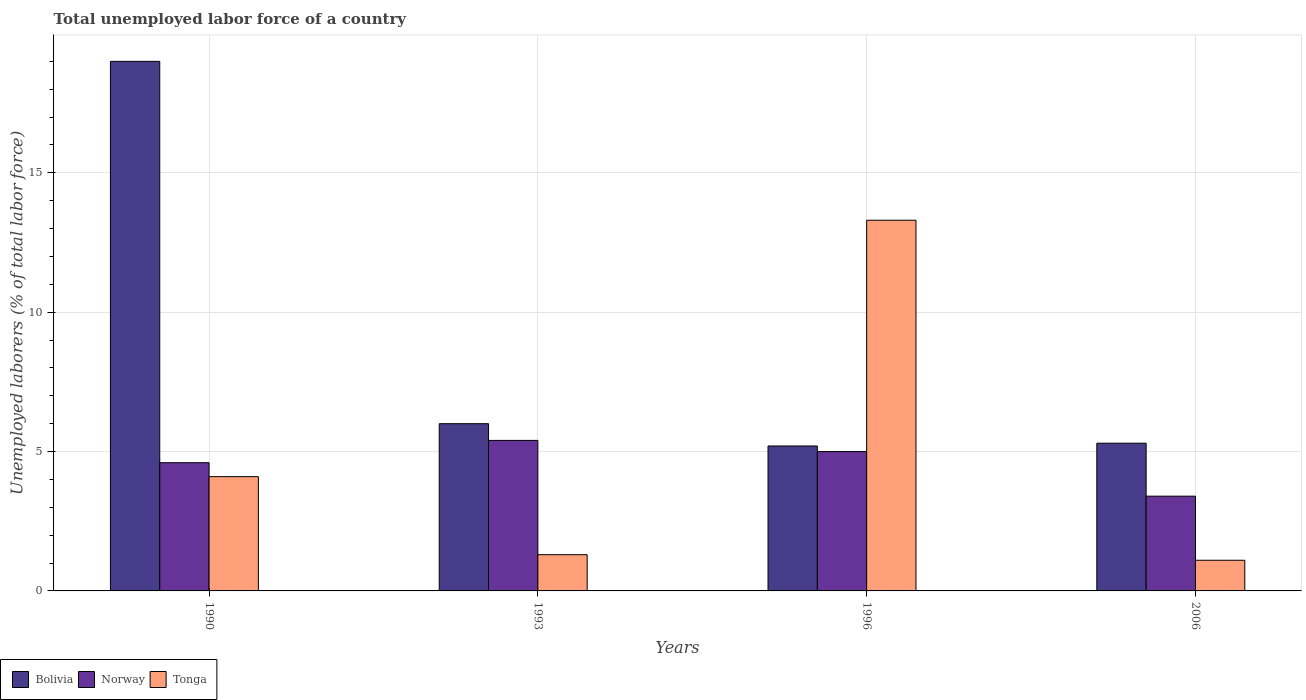How many different coloured bars are there?
Offer a terse response. 3. Are the number of bars on each tick of the X-axis equal?
Offer a terse response. Yes. How many bars are there on the 2nd tick from the right?
Provide a succinct answer. 3. What is the label of the 3rd group of bars from the left?
Your response must be concise. 1996. In how many cases, is the number of bars for a given year not equal to the number of legend labels?
Your answer should be very brief. 0. Across all years, what is the maximum total unemployed labor force in Norway?
Ensure brevity in your answer.  5.4. Across all years, what is the minimum total unemployed labor force in Bolivia?
Give a very brief answer. 5.2. In which year was the total unemployed labor force in Tonga maximum?
Make the answer very short. 1996. What is the total total unemployed labor force in Bolivia in the graph?
Your answer should be compact. 35.5. What is the difference between the total unemployed labor force in Norway in 1990 and that in 2006?
Give a very brief answer. 1.2. What is the difference between the total unemployed labor force in Norway in 1993 and the total unemployed labor force in Bolivia in 1996?
Provide a short and direct response. 0.2. What is the average total unemployed labor force in Tonga per year?
Make the answer very short. 4.95. In the year 2006, what is the difference between the total unemployed labor force in Tonga and total unemployed labor force in Norway?
Your response must be concise. -2.3. In how many years, is the total unemployed labor force in Bolivia greater than 16 %?
Your response must be concise. 1. What is the ratio of the total unemployed labor force in Bolivia in 1990 to that in 1993?
Offer a terse response. 3.17. Is the total unemployed labor force in Norway in 1996 less than that in 2006?
Your answer should be very brief. No. What is the difference between the highest and the second highest total unemployed labor force in Tonga?
Offer a very short reply. 9.2. What is the difference between the highest and the lowest total unemployed labor force in Bolivia?
Provide a succinct answer. 13.8. In how many years, is the total unemployed labor force in Bolivia greater than the average total unemployed labor force in Bolivia taken over all years?
Give a very brief answer. 1. What does the 3rd bar from the left in 1996 represents?
Provide a succinct answer. Tonga. What does the 1st bar from the right in 2006 represents?
Offer a very short reply. Tonga. Are all the bars in the graph horizontal?
Ensure brevity in your answer.  No. How many years are there in the graph?
Offer a very short reply. 4. What is the difference between two consecutive major ticks on the Y-axis?
Ensure brevity in your answer.  5. How many legend labels are there?
Your answer should be compact. 3. How are the legend labels stacked?
Keep it short and to the point. Horizontal. What is the title of the graph?
Provide a short and direct response. Total unemployed labor force of a country. What is the label or title of the X-axis?
Ensure brevity in your answer.  Years. What is the label or title of the Y-axis?
Offer a terse response. Unemployed laborers (% of total labor force). What is the Unemployed laborers (% of total labor force) in Bolivia in 1990?
Offer a very short reply. 19. What is the Unemployed laborers (% of total labor force) in Norway in 1990?
Give a very brief answer. 4.6. What is the Unemployed laborers (% of total labor force) in Tonga in 1990?
Offer a terse response. 4.1. What is the Unemployed laborers (% of total labor force) of Norway in 1993?
Provide a short and direct response. 5.4. What is the Unemployed laborers (% of total labor force) in Tonga in 1993?
Offer a very short reply. 1.3. What is the Unemployed laborers (% of total labor force) of Bolivia in 1996?
Your response must be concise. 5.2. What is the Unemployed laborers (% of total labor force) of Norway in 1996?
Provide a succinct answer. 5. What is the Unemployed laborers (% of total labor force) of Tonga in 1996?
Your answer should be very brief. 13.3. What is the Unemployed laborers (% of total labor force) of Bolivia in 2006?
Keep it short and to the point. 5.3. What is the Unemployed laborers (% of total labor force) of Norway in 2006?
Provide a succinct answer. 3.4. What is the Unemployed laborers (% of total labor force) of Tonga in 2006?
Make the answer very short. 1.1. Across all years, what is the maximum Unemployed laborers (% of total labor force) in Bolivia?
Make the answer very short. 19. Across all years, what is the maximum Unemployed laborers (% of total labor force) in Norway?
Provide a succinct answer. 5.4. Across all years, what is the maximum Unemployed laborers (% of total labor force) in Tonga?
Your response must be concise. 13.3. Across all years, what is the minimum Unemployed laborers (% of total labor force) in Bolivia?
Ensure brevity in your answer.  5.2. Across all years, what is the minimum Unemployed laborers (% of total labor force) in Norway?
Provide a short and direct response. 3.4. Across all years, what is the minimum Unemployed laborers (% of total labor force) of Tonga?
Keep it short and to the point. 1.1. What is the total Unemployed laborers (% of total labor force) in Bolivia in the graph?
Your answer should be very brief. 35.5. What is the total Unemployed laborers (% of total labor force) in Tonga in the graph?
Your answer should be very brief. 19.8. What is the difference between the Unemployed laborers (% of total labor force) of Norway in 1990 and that in 1996?
Keep it short and to the point. -0.4. What is the difference between the Unemployed laborers (% of total labor force) in Tonga in 1990 and that in 1996?
Your answer should be very brief. -9.2. What is the difference between the Unemployed laborers (% of total labor force) in Tonga in 1990 and that in 2006?
Make the answer very short. 3. What is the difference between the Unemployed laborers (% of total labor force) of Bolivia in 1993 and that in 1996?
Your answer should be compact. 0.8. What is the difference between the Unemployed laborers (% of total labor force) of Tonga in 1993 and that in 1996?
Provide a short and direct response. -12. What is the difference between the Unemployed laborers (% of total labor force) in Tonga in 1996 and that in 2006?
Your answer should be compact. 12.2. What is the difference between the Unemployed laborers (% of total labor force) in Bolivia in 1990 and the Unemployed laborers (% of total labor force) in Norway in 1993?
Your answer should be compact. 13.6. What is the difference between the Unemployed laborers (% of total labor force) in Norway in 1990 and the Unemployed laborers (% of total labor force) in Tonga in 1993?
Provide a succinct answer. 3.3. What is the difference between the Unemployed laborers (% of total labor force) in Norway in 1990 and the Unemployed laborers (% of total labor force) in Tonga in 1996?
Keep it short and to the point. -8.7. What is the difference between the Unemployed laborers (% of total labor force) of Bolivia in 1990 and the Unemployed laborers (% of total labor force) of Norway in 2006?
Ensure brevity in your answer.  15.6. What is the difference between the Unemployed laborers (% of total labor force) in Bolivia in 1990 and the Unemployed laborers (% of total labor force) in Tonga in 2006?
Your answer should be very brief. 17.9. What is the difference between the Unemployed laborers (% of total labor force) of Norway in 1990 and the Unemployed laborers (% of total labor force) of Tonga in 2006?
Keep it short and to the point. 3.5. What is the difference between the Unemployed laborers (% of total labor force) of Bolivia in 1993 and the Unemployed laborers (% of total labor force) of Norway in 2006?
Your response must be concise. 2.6. What is the difference between the Unemployed laborers (% of total labor force) in Bolivia in 1993 and the Unemployed laborers (% of total labor force) in Tonga in 2006?
Offer a very short reply. 4.9. What is the difference between the Unemployed laborers (% of total labor force) of Bolivia in 1996 and the Unemployed laborers (% of total labor force) of Norway in 2006?
Give a very brief answer. 1.8. What is the difference between the Unemployed laborers (% of total labor force) in Norway in 1996 and the Unemployed laborers (% of total labor force) in Tonga in 2006?
Give a very brief answer. 3.9. What is the average Unemployed laborers (% of total labor force) in Bolivia per year?
Give a very brief answer. 8.88. What is the average Unemployed laborers (% of total labor force) of Tonga per year?
Offer a terse response. 4.95. In the year 1990, what is the difference between the Unemployed laborers (% of total labor force) of Bolivia and Unemployed laborers (% of total labor force) of Tonga?
Ensure brevity in your answer.  14.9. In the year 1990, what is the difference between the Unemployed laborers (% of total labor force) of Norway and Unemployed laborers (% of total labor force) of Tonga?
Your answer should be very brief. 0.5. In the year 1996, what is the difference between the Unemployed laborers (% of total labor force) of Bolivia and Unemployed laborers (% of total labor force) of Norway?
Offer a very short reply. 0.2. In the year 1996, what is the difference between the Unemployed laborers (% of total labor force) of Bolivia and Unemployed laborers (% of total labor force) of Tonga?
Keep it short and to the point. -8.1. In the year 2006, what is the difference between the Unemployed laborers (% of total labor force) of Bolivia and Unemployed laborers (% of total labor force) of Norway?
Provide a short and direct response. 1.9. In the year 2006, what is the difference between the Unemployed laborers (% of total labor force) of Bolivia and Unemployed laborers (% of total labor force) of Tonga?
Offer a terse response. 4.2. In the year 2006, what is the difference between the Unemployed laborers (% of total labor force) of Norway and Unemployed laborers (% of total labor force) of Tonga?
Make the answer very short. 2.3. What is the ratio of the Unemployed laborers (% of total labor force) in Bolivia in 1990 to that in 1993?
Give a very brief answer. 3.17. What is the ratio of the Unemployed laborers (% of total labor force) in Norway in 1990 to that in 1993?
Provide a short and direct response. 0.85. What is the ratio of the Unemployed laborers (% of total labor force) in Tonga in 1990 to that in 1993?
Ensure brevity in your answer.  3.15. What is the ratio of the Unemployed laborers (% of total labor force) in Bolivia in 1990 to that in 1996?
Ensure brevity in your answer.  3.65. What is the ratio of the Unemployed laborers (% of total labor force) in Norway in 1990 to that in 1996?
Your answer should be very brief. 0.92. What is the ratio of the Unemployed laborers (% of total labor force) of Tonga in 1990 to that in 1996?
Offer a terse response. 0.31. What is the ratio of the Unemployed laborers (% of total labor force) of Bolivia in 1990 to that in 2006?
Keep it short and to the point. 3.58. What is the ratio of the Unemployed laborers (% of total labor force) in Norway in 1990 to that in 2006?
Offer a very short reply. 1.35. What is the ratio of the Unemployed laborers (% of total labor force) of Tonga in 1990 to that in 2006?
Provide a short and direct response. 3.73. What is the ratio of the Unemployed laborers (% of total labor force) in Bolivia in 1993 to that in 1996?
Keep it short and to the point. 1.15. What is the ratio of the Unemployed laborers (% of total labor force) of Tonga in 1993 to that in 1996?
Keep it short and to the point. 0.1. What is the ratio of the Unemployed laborers (% of total labor force) of Bolivia in 1993 to that in 2006?
Provide a short and direct response. 1.13. What is the ratio of the Unemployed laborers (% of total labor force) in Norway in 1993 to that in 2006?
Your answer should be compact. 1.59. What is the ratio of the Unemployed laborers (% of total labor force) in Tonga in 1993 to that in 2006?
Offer a terse response. 1.18. What is the ratio of the Unemployed laborers (% of total labor force) of Bolivia in 1996 to that in 2006?
Provide a succinct answer. 0.98. What is the ratio of the Unemployed laborers (% of total labor force) in Norway in 1996 to that in 2006?
Make the answer very short. 1.47. What is the ratio of the Unemployed laborers (% of total labor force) in Tonga in 1996 to that in 2006?
Give a very brief answer. 12.09. What is the difference between the highest and the second highest Unemployed laborers (% of total labor force) of Tonga?
Keep it short and to the point. 9.2. What is the difference between the highest and the lowest Unemployed laborers (% of total labor force) of Bolivia?
Your answer should be very brief. 13.8. What is the difference between the highest and the lowest Unemployed laborers (% of total labor force) of Norway?
Give a very brief answer. 2. What is the difference between the highest and the lowest Unemployed laborers (% of total labor force) in Tonga?
Provide a short and direct response. 12.2. 